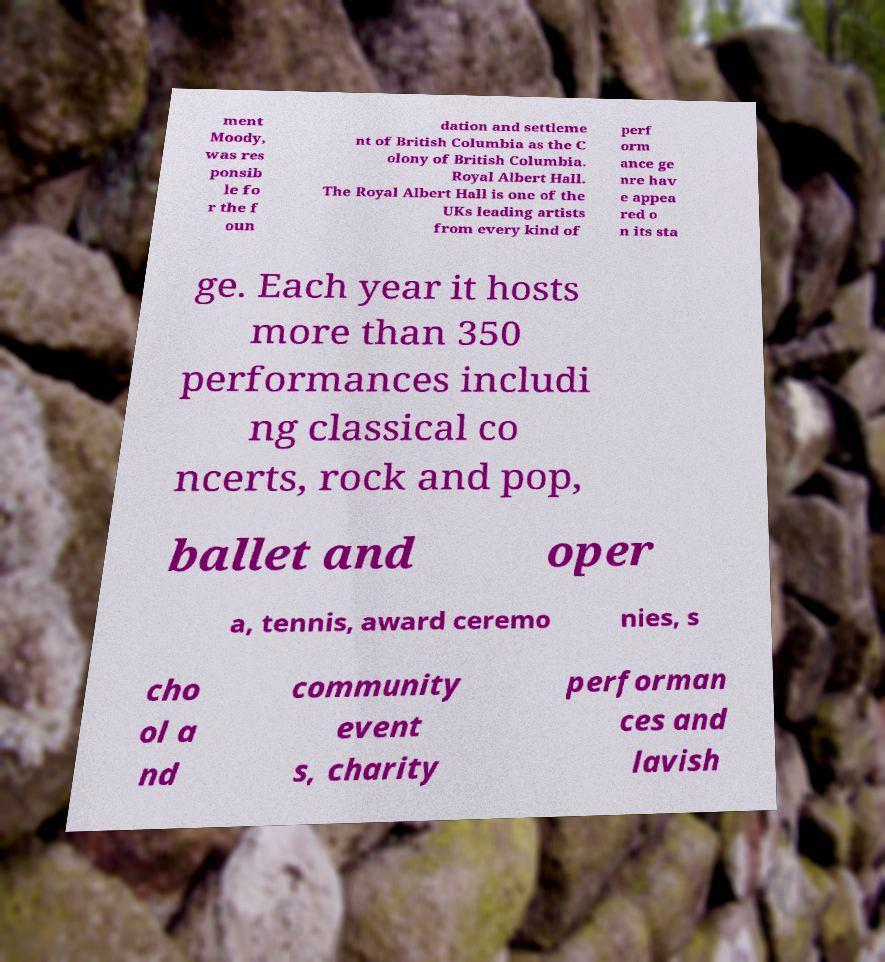What messages or text are displayed in this image? I need them in a readable, typed format. ment Moody, was res ponsib le fo r the f oun dation and settleme nt of British Columbia as the C olony of British Columbia. Royal Albert Hall. The Royal Albert Hall is one of the UKs leading artists from every kind of perf orm ance ge nre hav e appea red o n its sta ge. Each year it hosts more than 350 performances includi ng classical co ncerts, rock and pop, ballet and oper a, tennis, award ceremo nies, s cho ol a nd community event s, charity performan ces and lavish 